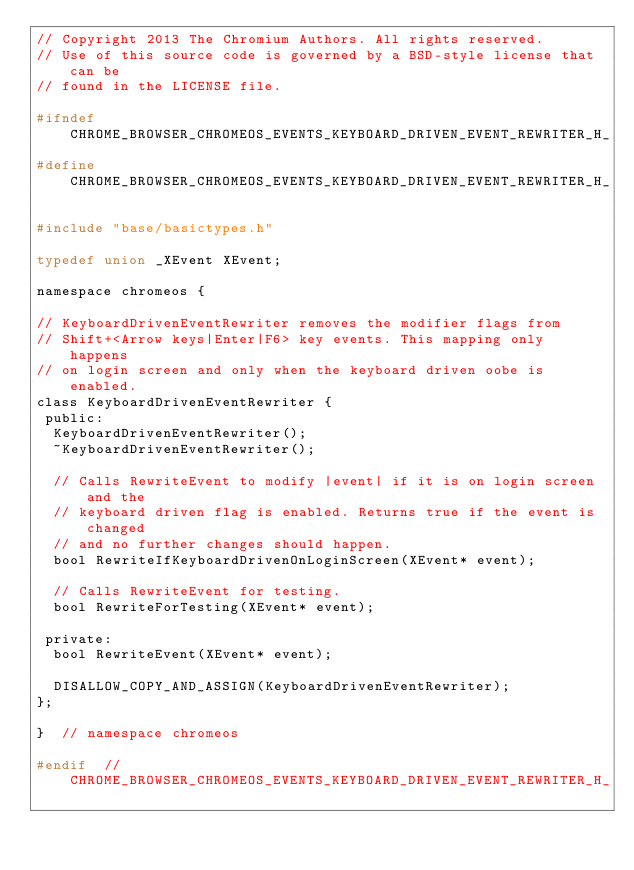<code> <loc_0><loc_0><loc_500><loc_500><_C_>// Copyright 2013 The Chromium Authors. All rights reserved.
// Use of this source code is governed by a BSD-style license that can be
// found in the LICENSE file.

#ifndef CHROME_BROWSER_CHROMEOS_EVENTS_KEYBOARD_DRIVEN_EVENT_REWRITER_H_
#define CHROME_BROWSER_CHROMEOS_EVENTS_KEYBOARD_DRIVEN_EVENT_REWRITER_H_

#include "base/basictypes.h"

typedef union _XEvent XEvent;

namespace chromeos {

// KeyboardDrivenEventRewriter removes the modifier flags from
// Shift+<Arrow keys|Enter|F6> key events. This mapping only happens
// on login screen and only when the keyboard driven oobe is enabled.
class KeyboardDrivenEventRewriter {
 public:
  KeyboardDrivenEventRewriter();
  ~KeyboardDrivenEventRewriter();

  // Calls RewriteEvent to modify |event| if it is on login screen and the
  // keyboard driven flag is enabled. Returns true if the event is changed
  // and no further changes should happen.
  bool RewriteIfKeyboardDrivenOnLoginScreen(XEvent* event);

  // Calls RewriteEvent for testing.
  bool RewriteForTesting(XEvent* event);

 private:
  bool RewriteEvent(XEvent* event);

  DISALLOW_COPY_AND_ASSIGN(KeyboardDrivenEventRewriter);
};

}  // namespace chromeos

#endif  // CHROME_BROWSER_CHROMEOS_EVENTS_KEYBOARD_DRIVEN_EVENT_REWRITER_H_
</code> 